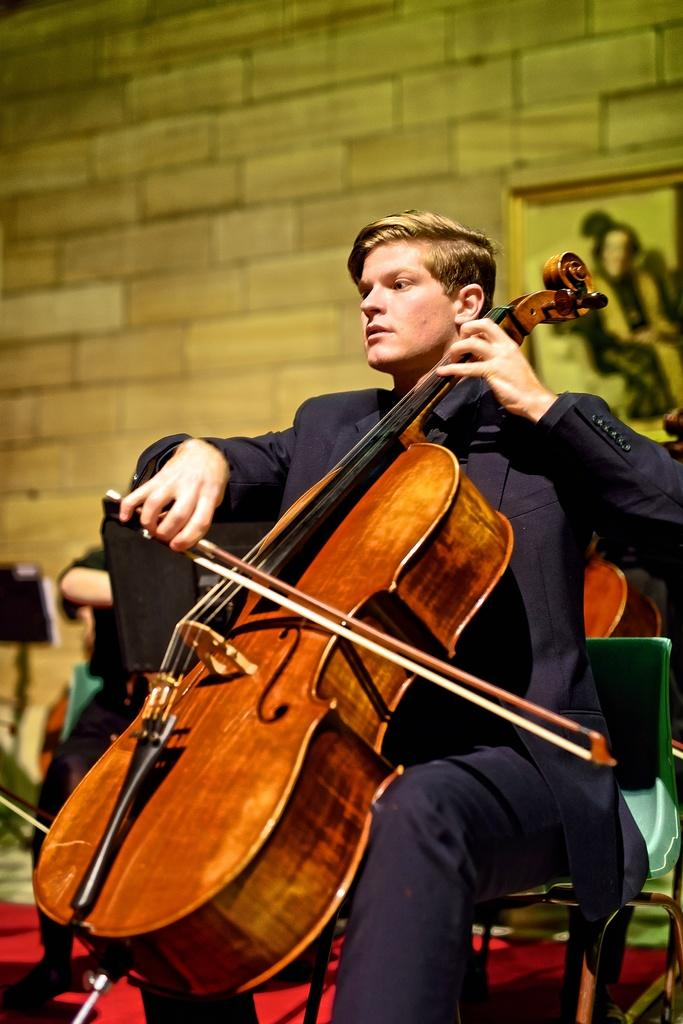What is the main subject of the image? The main subject of the image is a person. What is the person doing in the image? The person is sitting on a chair and playing a musical instrument. What type of light can be seen illuminating the pizzas in the image? There are no pizzas present in the image, and therefore no light illuminating them. What type of wind can be seen blowing through the zephyr in the image? There is no zephyr present in the image. 